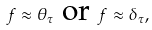Convert formula to latex. <formula><loc_0><loc_0><loc_500><loc_500>f \approx \theta _ { \tau } \text { or } f \approx \delta _ { \tau } ,</formula> 